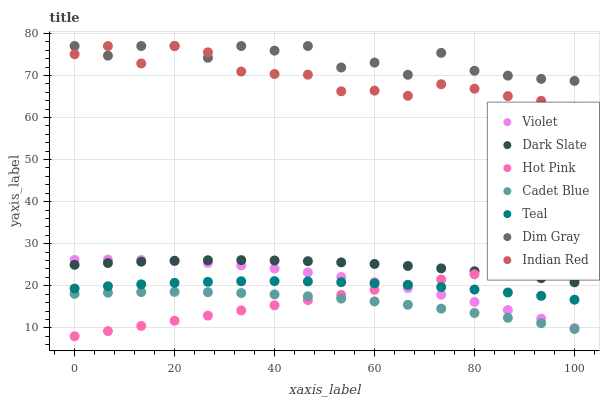Does Cadet Blue have the minimum area under the curve?
Answer yes or no. Yes. Does Dim Gray have the maximum area under the curve?
Answer yes or no. Yes. Does Indian Red have the minimum area under the curve?
Answer yes or no. No. Does Indian Red have the maximum area under the curve?
Answer yes or no. No. Is Hot Pink the smoothest?
Answer yes or no. Yes. Is Dim Gray the roughest?
Answer yes or no. Yes. Is Indian Red the smoothest?
Answer yes or no. No. Is Indian Red the roughest?
Answer yes or no. No. Does Hot Pink have the lowest value?
Answer yes or no. Yes. Does Indian Red have the lowest value?
Answer yes or no. No. Does Dim Gray have the highest value?
Answer yes or no. Yes. Does Hot Pink have the highest value?
Answer yes or no. No. Is Dark Slate less than Dim Gray?
Answer yes or no. Yes. Is Dim Gray greater than Cadet Blue?
Answer yes or no. Yes. Does Hot Pink intersect Dark Slate?
Answer yes or no. Yes. Is Hot Pink less than Dark Slate?
Answer yes or no. No. Is Hot Pink greater than Dark Slate?
Answer yes or no. No. Does Dark Slate intersect Dim Gray?
Answer yes or no. No. 